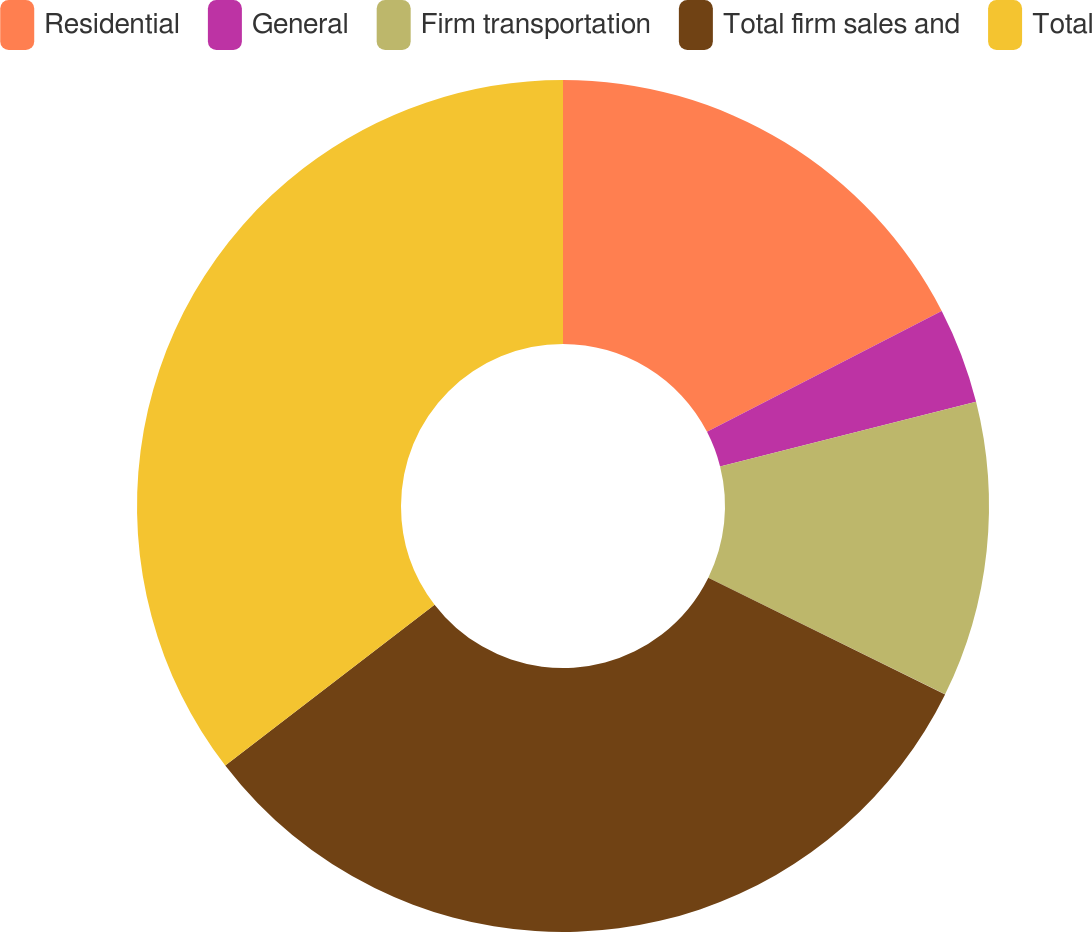Convert chart to OTSL. <chart><loc_0><loc_0><loc_500><loc_500><pie_chart><fcel>Residential<fcel>General<fcel>Firm transportation<fcel>Total firm sales and<fcel>Total<nl><fcel>17.43%<fcel>3.64%<fcel>11.22%<fcel>32.28%<fcel>35.43%<nl></chart> 